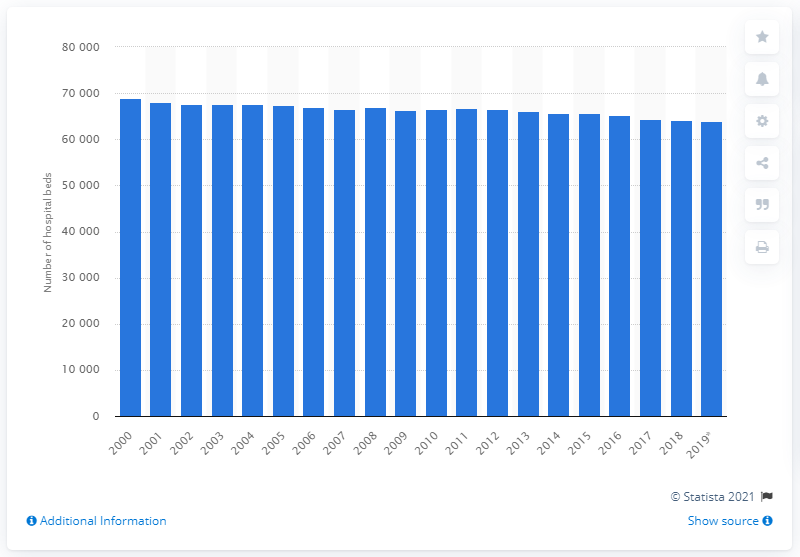Indicate a few pertinent items in this graphic. By the year 2019, there were approximately 63,962 hospital beds in Belgium. Since the year 2000, the number of hospital beds in Belgium has generally declined. 